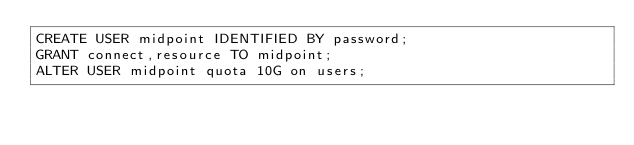<code> <loc_0><loc_0><loc_500><loc_500><_SQL_>CREATE USER midpoint IDENTIFIED BY password;
GRANT connect,resource TO midpoint;
ALTER USER midpoint quota 10G on users;
</code> 